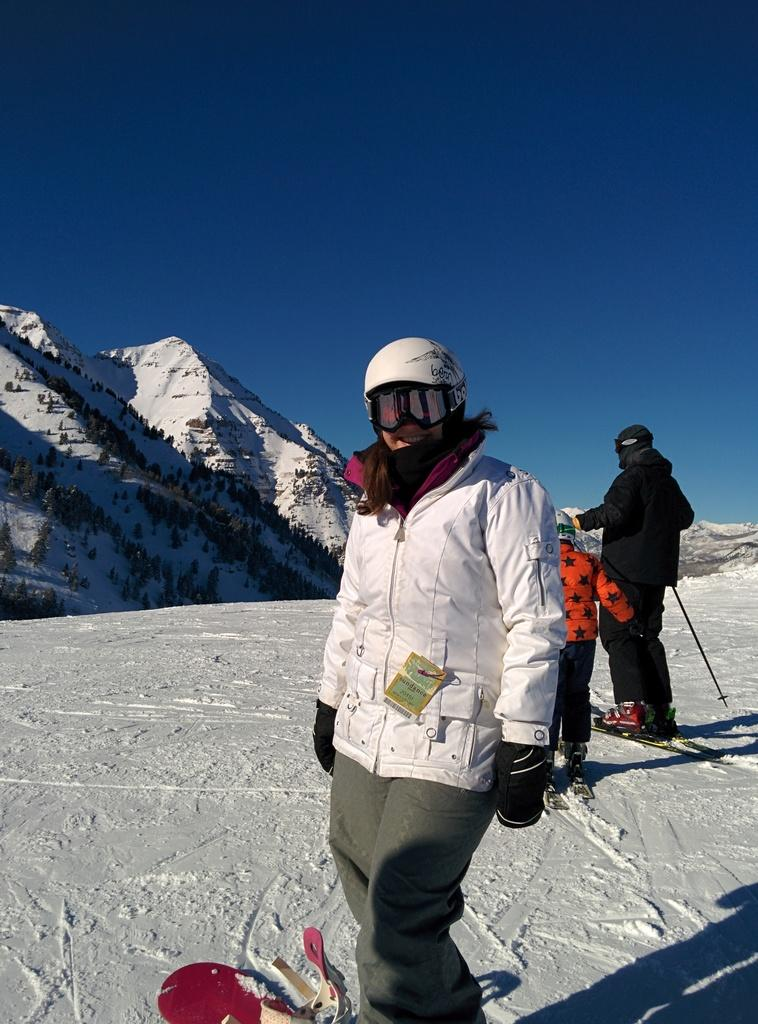What type of weather condition is depicted in the image? There is snow in the image. What are the people doing in the snow? People are standing on the surface and skiing in the image. What geographical feature can be seen in the background? There is a mountain visible in the image. What is visible in the sky? Clouds are present in the sky. What type of jelly can be seen on the mountain in the image? There is no jelly present in the image; it features snow, people, and a mountain. What type of teeth can be seen on the people skiing in the image? There is no indication of the people's teeth in the image, as their faces are not visible. 